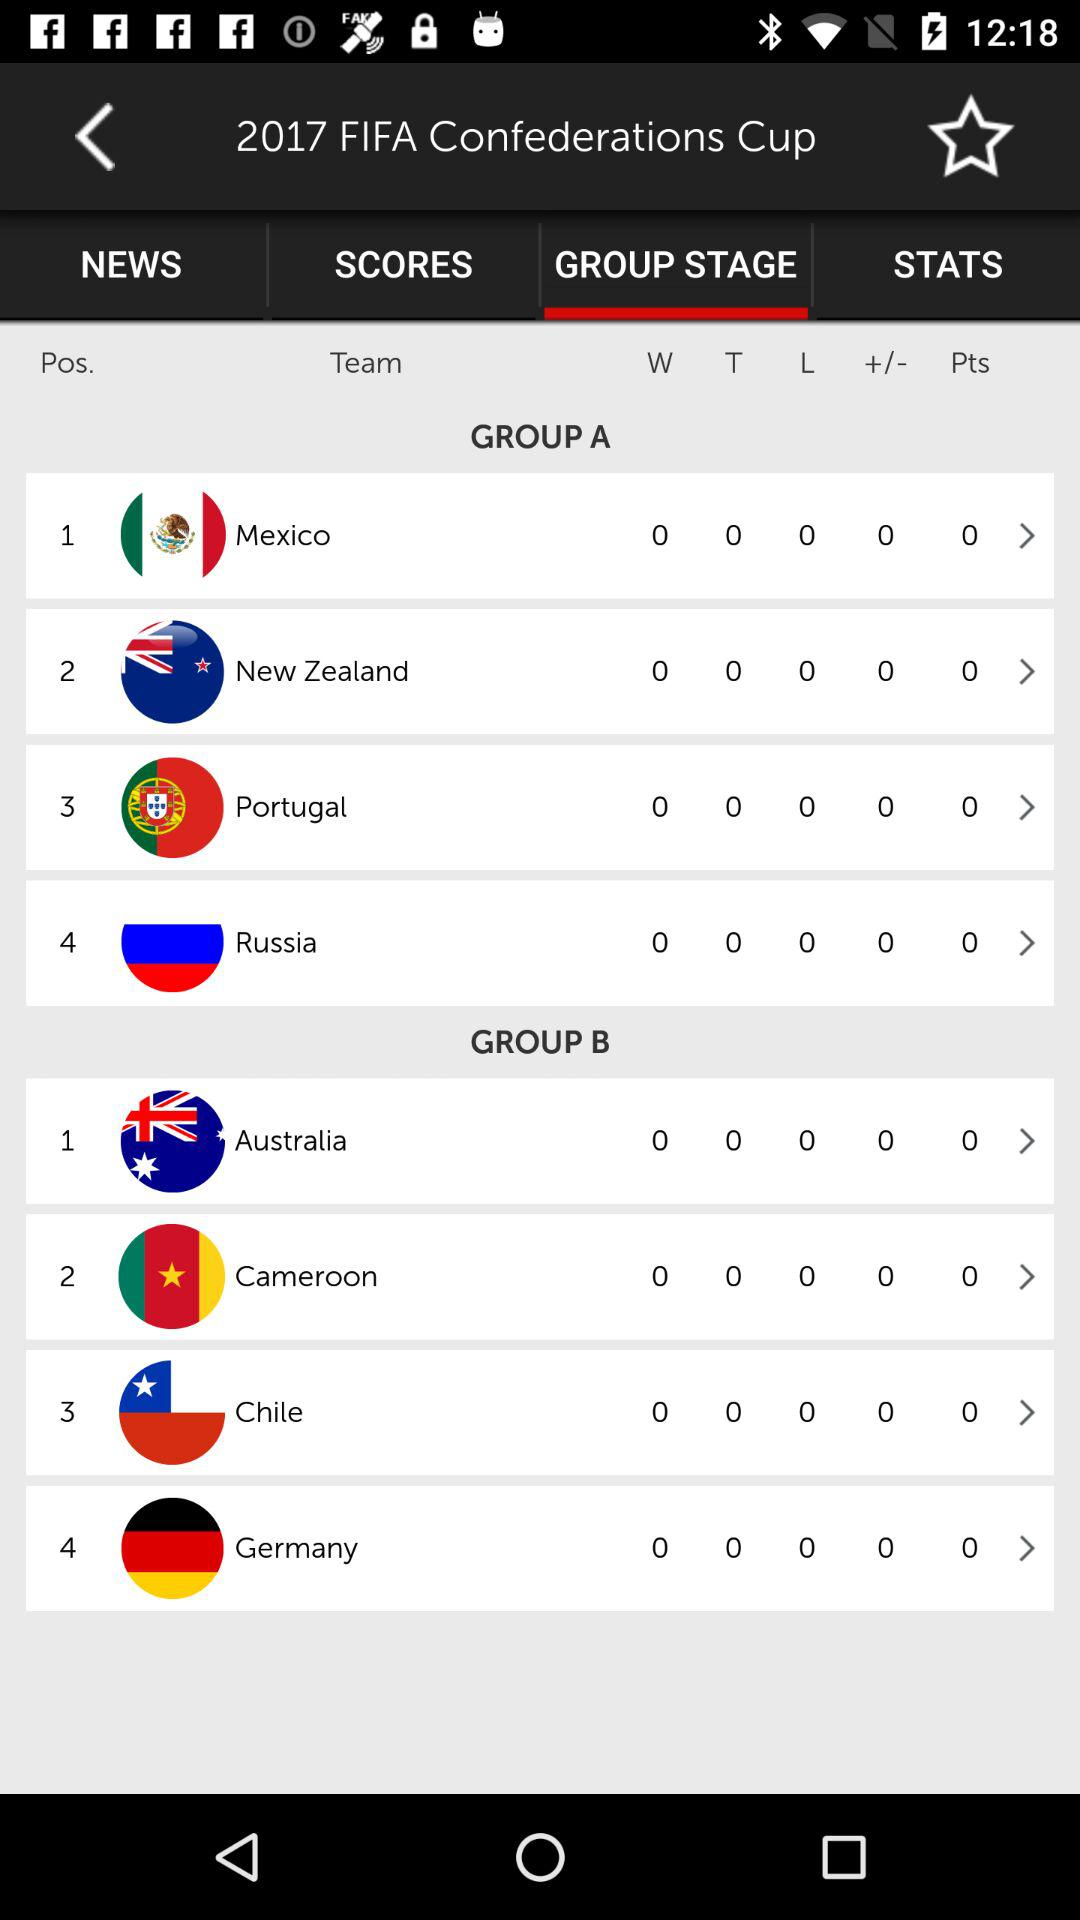What is the selected tab? The selected tab is "GROUP STAGE". 